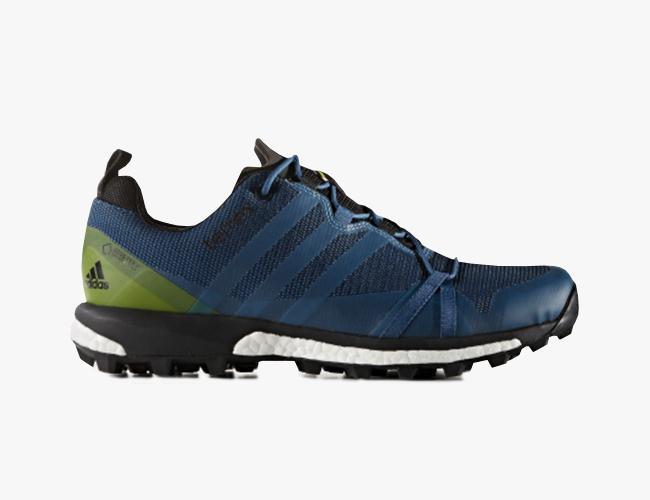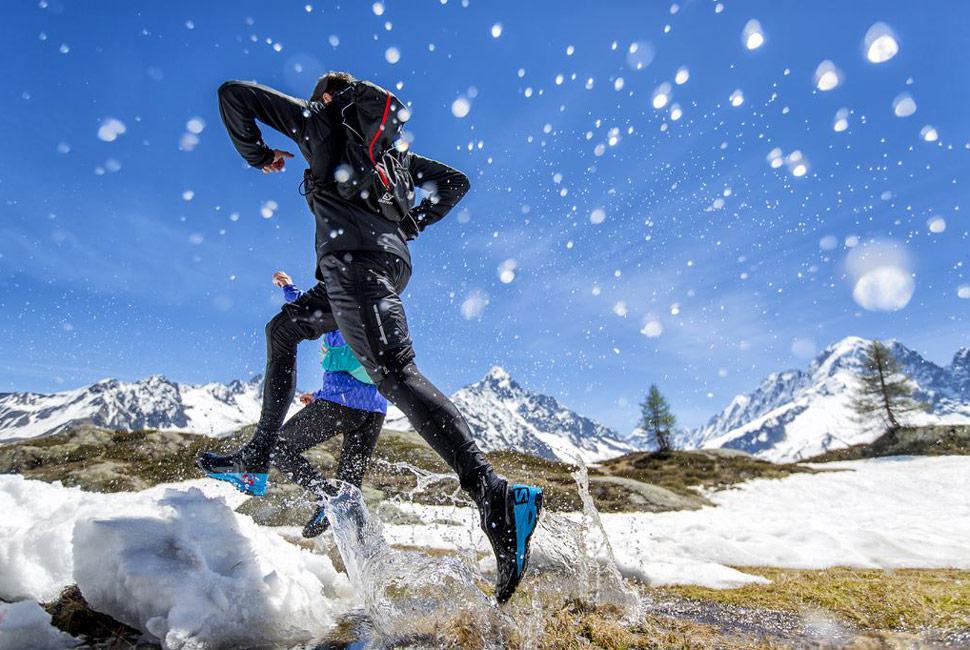The first image is the image on the left, the second image is the image on the right. Given the left and right images, does the statement "there is humans in the right side image" hold true? Answer yes or no. Yes. The first image is the image on the left, the second image is the image on the right. For the images displayed, is the sentence "There are two people running on the pavement." factually correct? Answer yes or no. No. The first image is the image on the left, the second image is the image on the right. Assess this claim about the two images: "There is an image of a single shoe pointing to the right.". Correct or not? Answer yes or no. Yes. The first image is the image on the left, the second image is the image on the right. For the images displayed, is the sentence "In one image there are two people running outside with snow on the ground." factually correct? Answer yes or no. Yes. 